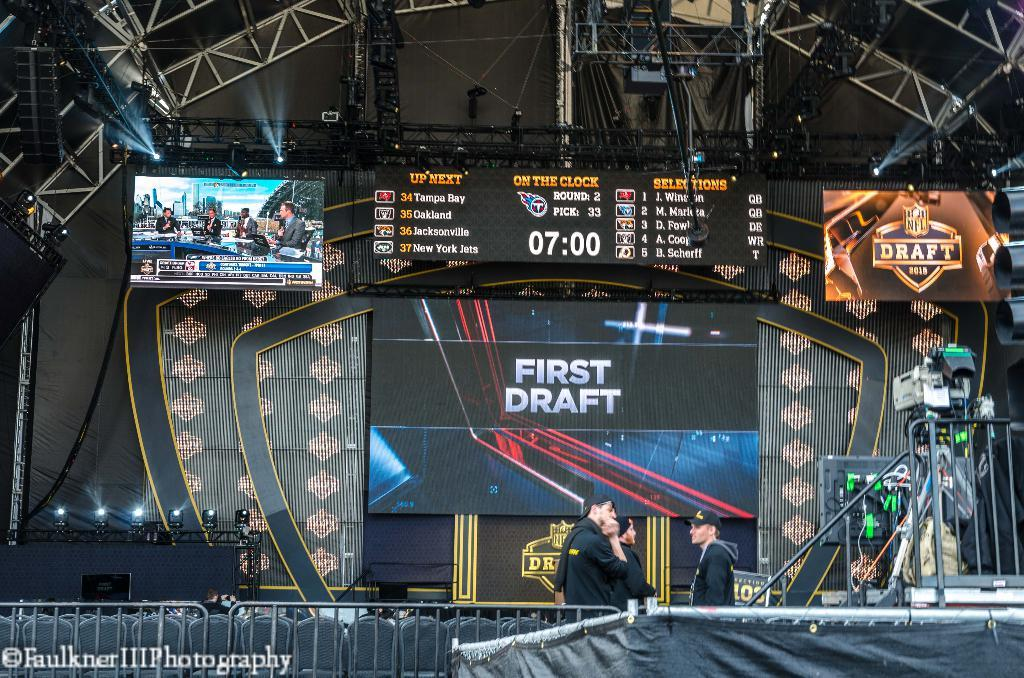<image>
Offer a succinct explanation of the picture presented. The team on the clock is the Titans 